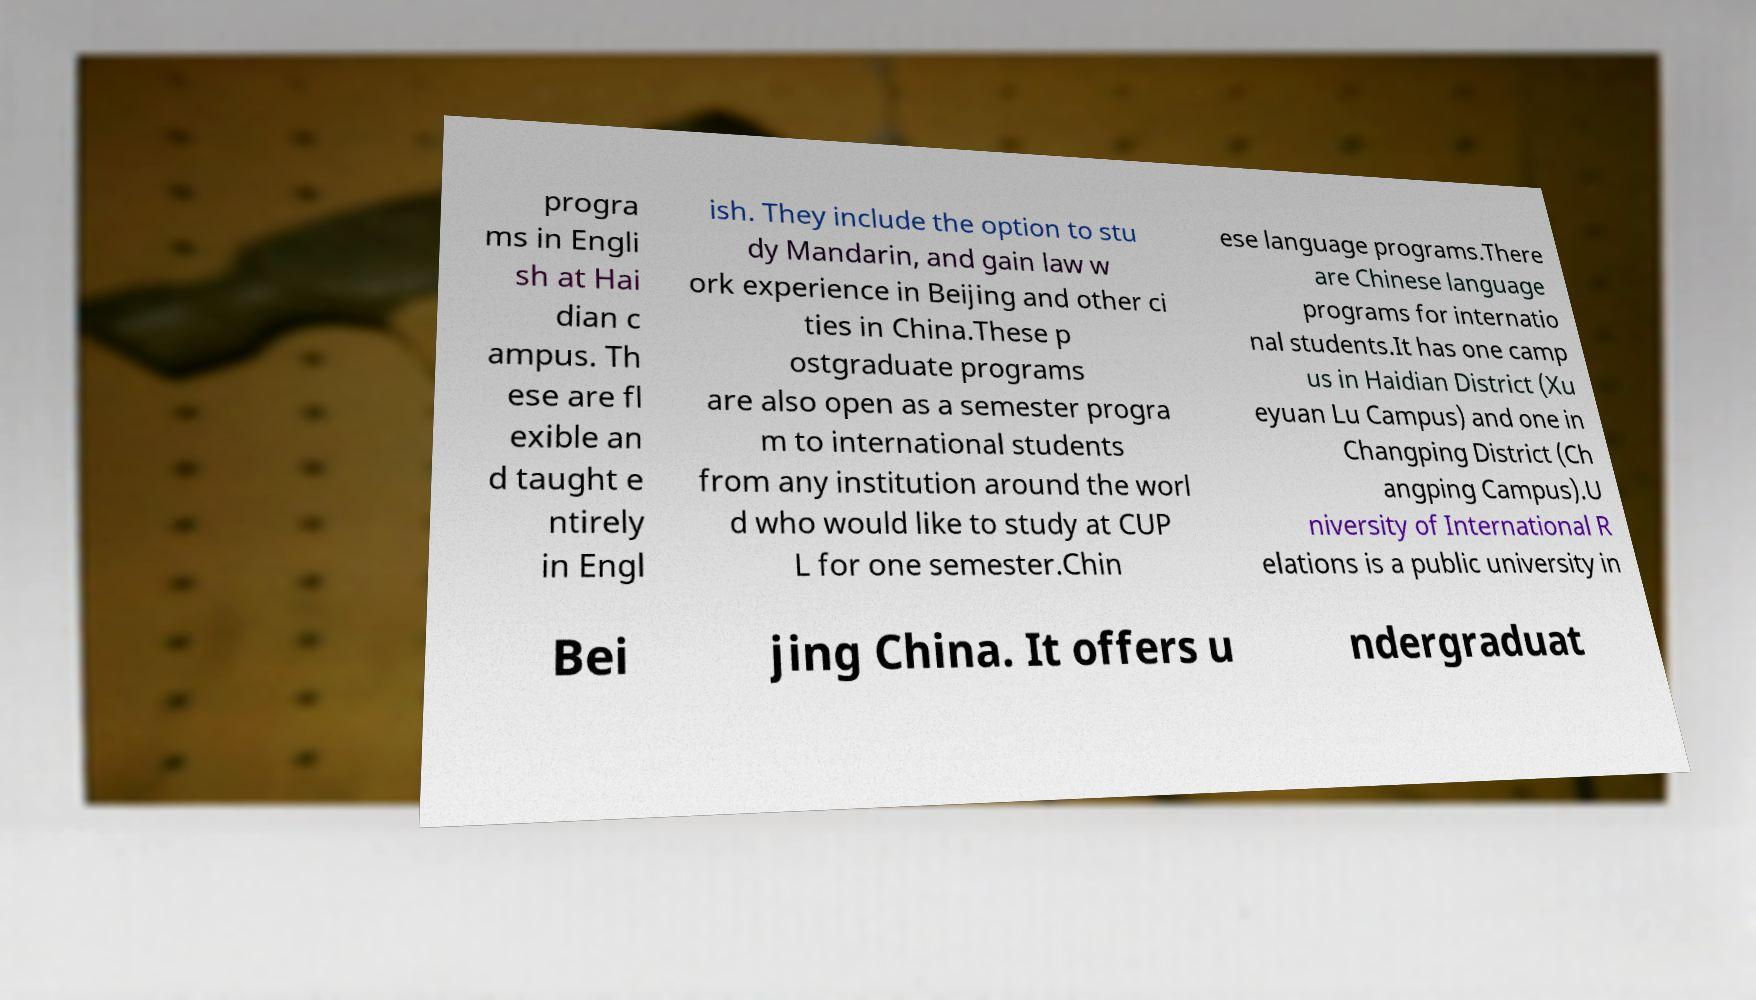For documentation purposes, I need the text within this image transcribed. Could you provide that? progra ms in Engli sh at Hai dian c ampus. Th ese are fl exible an d taught e ntirely in Engl ish. They include the option to stu dy Mandarin, and gain law w ork experience in Beijing and other ci ties in China.These p ostgraduate programs are also open as a semester progra m to international students from any institution around the worl d who would like to study at CUP L for one semester.Chin ese language programs.There are Chinese language programs for internatio nal students.It has one camp us in Haidian District (Xu eyuan Lu Campus) and one in Changping District (Ch angping Campus).U niversity of International R elations is a public university in Bei jing China. It offers u ndergraduat 